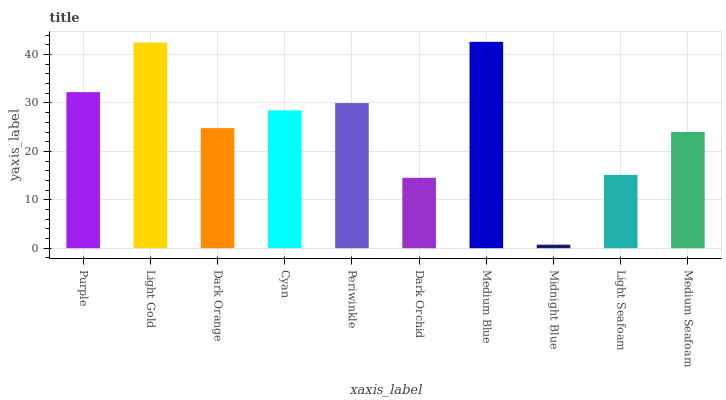Is Light Gold the minimum?
Answer yes or no. No. Is Light Gold the maximum?
Answer yes or no. No. Is Light Gold greater than Purple?
Answer yes or no. Yes. Is Purple less than Light Gold?
Answer yes or no. Yes. Is Purple greater than Light Gold?
Answer yes or no. No. Is Light Gold less than Purple?
Answer yes or no. No. Is Cyan the high median?
Answer yes or no. Yes. Is Dark Orange the low median?
Answer yes or no. Yes. Is Midnight Blue the high median?
Answer yes or no. No. Is Light Gold the low median?
Answer yes or no. No. 